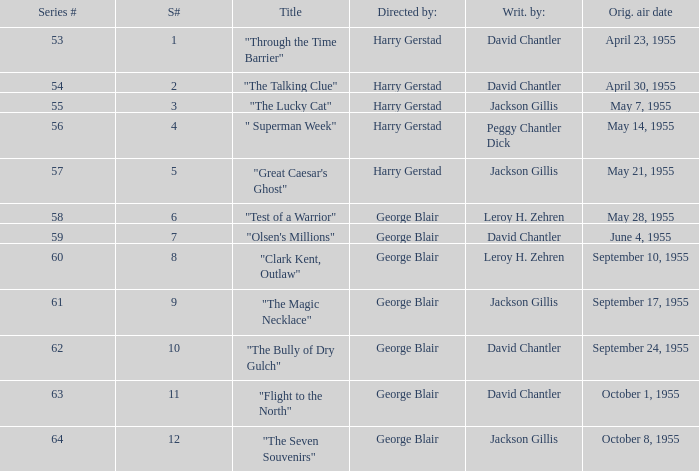When did season 9 originally air? September 17, 1955. 